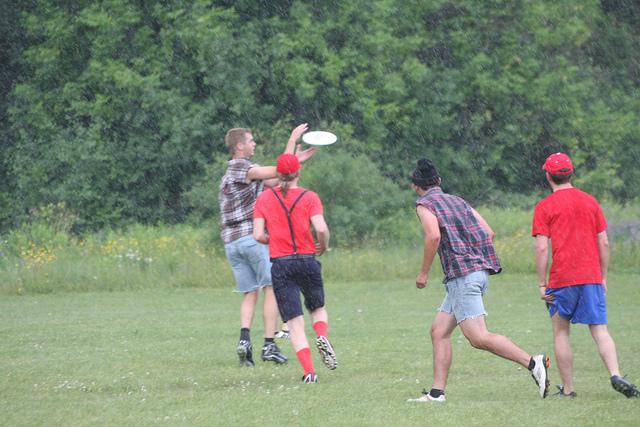What color are the shirts?
Concise answer only. Red. Are they playing a frisbee game?
Answer briefly. Yes. How many teammates are in this picture?
Quick response, please. 4. How many people are wearing red?
Write a very short answer. 2. Is this a public park?
Answer briefly. Yes. Is the grass trimmed?
Give a very brief answer. Yes. How many men are playing?
Be succinct. 4. Are men muscular?
Concise answer only. No. Are there the same number of players from each team in the scene?
Be succinct. Yes. What sport is being played?
Write a very short answer. Frisbee. 